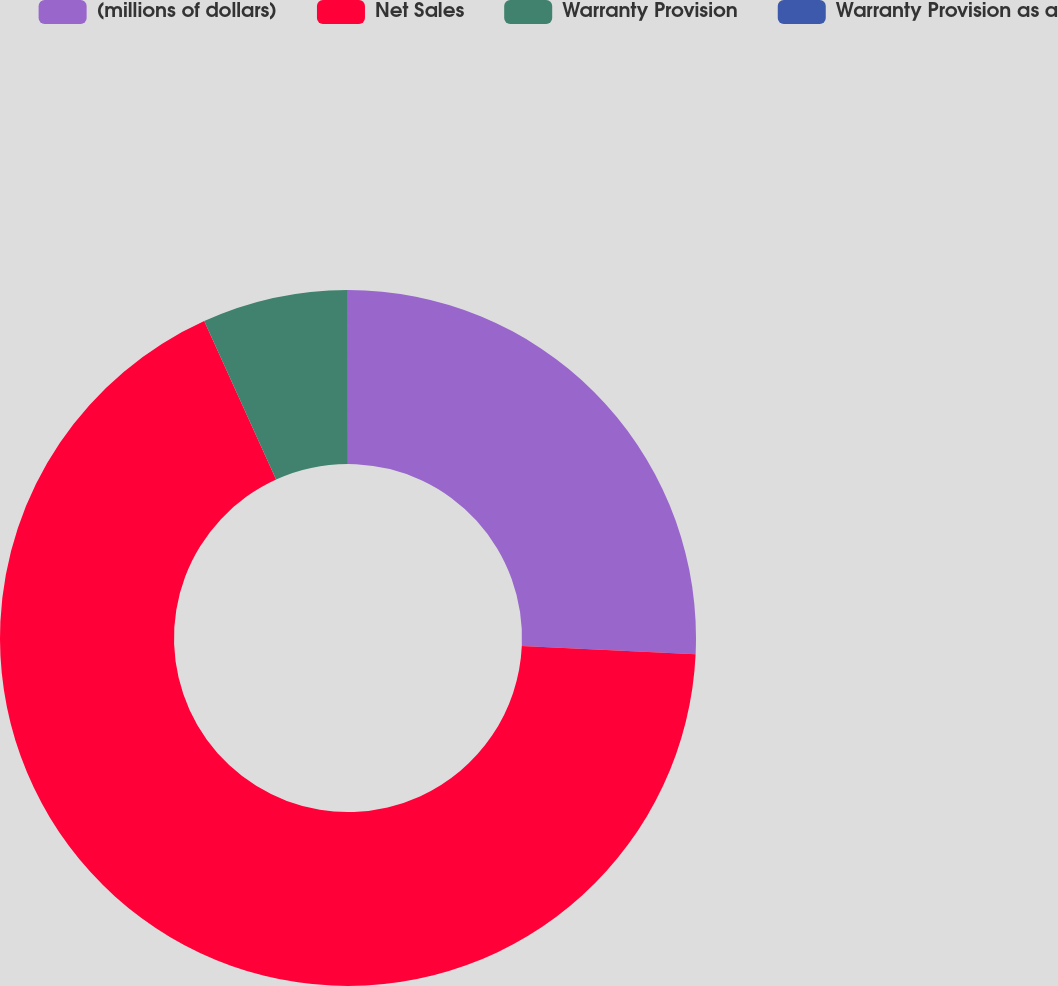<chart> <loc_0><loc_0><loc_500><loc_500><pie_chart><fcel>(millions of dollars)<fcel>Net Sales<fcel>Warranty Provision<fcel>Warranty Provision as a<nl><fcel>25.74%<fcel>67.48%<fcel>6.76%<fcel>0.02%<nl></chart> 